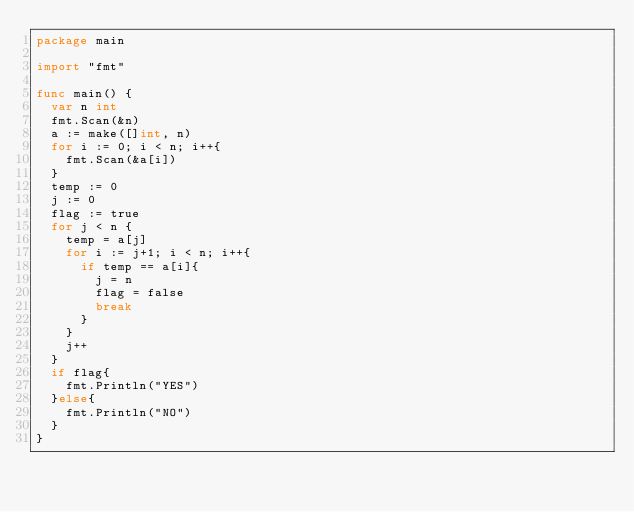<code> <loc_0><loc_0><loc_500><loc_500><_Go_>package main

import "fmt"

func main() {
	var n int
	fmt.Scan(&n)
	a := make([]int, n)
	for i := 0; i < n; i++{
		fmt.Scan(&a[i])
	}
	temp := 0
	j := 0
	flag := true
	for j < n {
		temp = a[j]
		for i := j+1; i < n; i++{
			if temp == a[i]{
				j = n
				flag = false
				break
			}
		}
		j++
	}
	if flag{
		fmt.Println("YES")
	}else{
		fmt.Println("NO")
	}
}</code> 